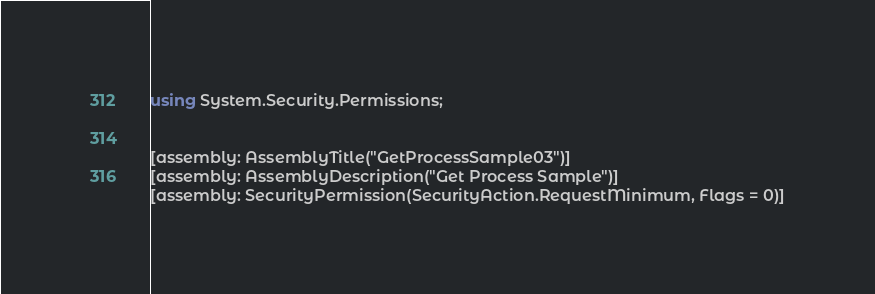<code> <loc_0><loc_0><loc_500><loc_500><_C#_>using System.Security.Permissions;


[assembly: AssemblyTitle("GetProcessSample03")]
[assembly: AssemblyDescription("Get Process Sample")]
[assembly: SecurityPermission(SecurityAction.RequestMinimum, Flags = 0)]
</code> 